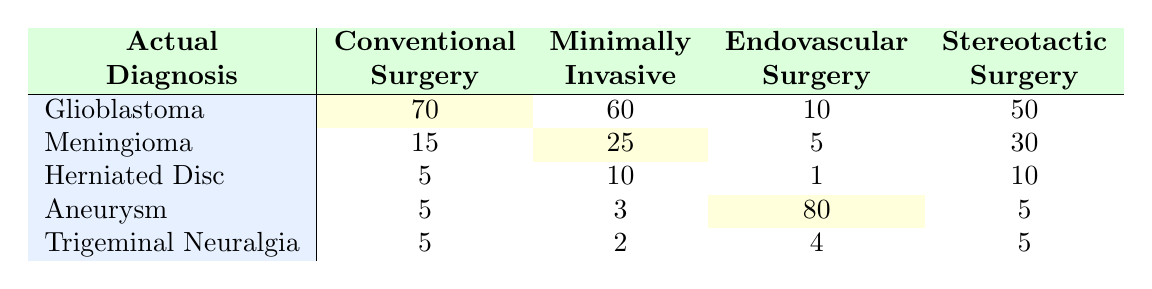What is the number of diagnoses predicted for Aneurysm using Endovascular Surgery? The table indicates the number of predicted diagnoses for Aneurysm under Endovascular Surgery is listed directly. According to the cell corresponding to Aneurysm and Endovascular Surgery, the value is 80.
Answer: 80 Which surgical method predicted the lowest diagnosis for Glioblastoma? To identify the surgical method with the lowest predicted diagnosis for Glioblastoma, we compare the values in the Glioblastoma row across all surgical methods. The values are 70 for Conventional Surgery, 60 for Minimally Invasive Surgery, 10 for Endovascular Surgery, and 50 for Stereotactic Surgery. The lowest value is 10, which corresponds to Endovascular Surgery.
Answer: Endovascular Surgery How many total predicted diagnoses were made for Meningioma across all methods? To find the total predicted diagnoses for Meningioma, we add the predicted values from all surgical methods: 15 (Conventional Surgery) + 25 (Minimally Invasive Surgery) + 5 (Endovascular Surgery) + 30 (Stereotactic Surgery) = 75.
Answer: 75 Is the predicted diagnosis for Trigeminal Neuralgia higher in Minimally Invasive Surgery than in Conventional Surgery? To answer this, we compare the predicted diagnoses for Trigeminal Neuralgia: 2 for Minimally Invasive Surgery and 5 for Conventional Surgery. Since 2 is less than 5, the statement is false.
Answer: No What is the average number of predictions for Herniated Disc across all surgical methods? To find the average number of predictions for Herniated Disc, we first sum the values: 5 (Conventional Surgery) + 10 (Minimally Invasive Surgery) + 1 (Endovascular Surgery) + 10 (Stereotactic Surgery) = 26. There are 4 surgical methods, so the average is 26/4 = 6.5.
Answer: 6.5 Which surgical method had the highest predicted diagnosis for Meningioma, and what was the value? In the Meningioma row, we look at the values for each surgical method: 15 (Conventional Surgery), 25 (Minimally Invasive Surgery), 5 (Endovascular Surgery), and 30 (Stereotactic Surgery). The highest value is 30, which is for Stereotactic Surgery.
Answer: Stereotactic Surgery, 30 Does the predicted diagnosis for Herniated Disc differ between Conventional Surgery and Stereotactic Surgery? Looking at the predicted diagnosis values, Herniated Disc has a value of 5 for Conventional Surgery and 10 for Stereotactic Surgery. Since 5 is not equal to 10, there is indeed a difference.
Answer: Yes What is the combined predicted number of diagnoses for Glioblastoma and Aneurysm using Stereotactic Surgery? We look at the predicted values for Glioblastoma and Aneurysm with Stereotactic Surgery: 50 for Glioblastoma and 5 for Aneurysm. Adding these together gives 50 + 5 = 55, which is the combined total.
Answer: 55 